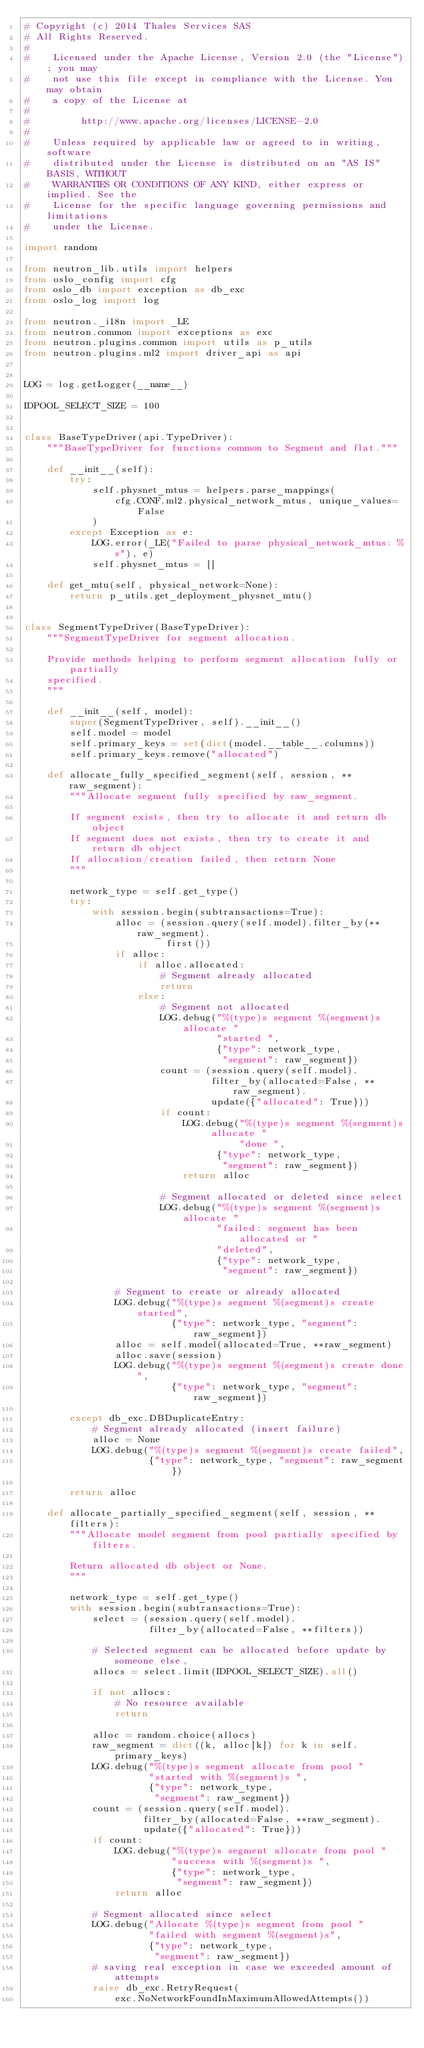Convert code to text. <code><loc_0><loc_0><loc_500><loc_500><_Python_># Copyright (c) 2014 Thales Services SAS
# All Rights Reserved.
#
#    Licensed under the Apache License, Version 2.0 (the "License"); you may
#    not use this file except in compliance with the License. You may obtain
#    a copy of the License at
#
#         http://www.apache.org/licenses/LICENSE-2.0
#
#    Unless required by applicable law or agreed to in writing, software
#    distributed under the License is distributed on an "AS IS" BASIS, WITHOUT
#    WARRANTIES OR CONDITIONS OF ANY KIND, either express or implied. See the
#    License for the specific language governing permissions and limitations
#    under the License.

import random

from neutron_lib.utils import helpers
from oslo_config import cfg
from oslo_db import exception as db_exc
from oslo_log import log

from neutron._i18n import _LE
from neutron.common import exceptions as exc
from neutron.plugins.common import utils as p_utils
from neutron.plugins.ml2 import driver_api as api


LOG = log.getLogger(__name__)

IDPOOL_SELECT_SIZE = 100


class BaseTypeDriver(api.TypeDriver):
    """BaseTypeDriver for functions common to Segment and flat."""

    def __init__(self):
        try:
            self.physnet_mtus = helpers.parse_mappings(
                cfg.CONF.ml2.physical_network_mtus, unique_values=False
            )
        except Exception as e:
            LOG.error(_LE("Failed to parse physical_network_mtus: %s"), e)
            self.physnet_mtus = []

    def get_mtu(self, physical_network=None):
        return p_utils.get_deployment_physnet_mtu()


class SegmentTypeDriver(BaseTypeDriver):
    """SegmentTypeDriver for segment allocation.

    Provide methods helping to perform segment allocation fully or partially
    specified.
    """

    def __init__(self, model):
        super(SegmentTypeDriver, self).__init__()
        self.model = model
        self.primary_keys = set(dict(model.__table__.columns))
        self.primary_keys.remove("allocated")

    def allocate_fully_specified_segment(self, session, **raw_segment):
        """Allocate segment fully specified by raw_segment.

        If segment exists, then try to allocate it and return db object
        If segment does not exists, then try to create it and return db object
        If allocation/creation failed, then return None
        """

        network_type = self.get_type()
        try:
            with session.begin(subtransactions=True):
                alloc = (session.query(self.model).filter_by(**raw_segment).
                         first())
                if alloc:
                    if alloc.allocated:
                        # Segment already allocated
                        return
                    else:
                        # Segment not allocated
                        LOG.debug("%(type)s segment %(segment)s allocate "
                                  "started ",
                                  {"type": network_type,
                                   "segment": raw_segment})
                        count = (session.query(self.model).
                                 filter_by(allocated=False, **raw_segment).
                                 update({"allocated": True}))
                        if count:
                            LOG.debug("%(type)s segment %(segment)s allocate "
                                      "done ",
                                  {"type": network_type,
                                   "segment": raw_segment})
                            return alloc

                        # Segment allocated or deleted since select
                        LOG.debug("%(type)s segment %(segment)s allocate "
                                  "failed: segment has been allocated or "
                                  "deleted",
                                  {"type": network_type,
                                   "segment": raw_segment})

                # Segment to create or already allocated
                LOG.debug("%(type)s segment %(segment)s create started",
                          {"type": network_type, "segment": raw_segment})
                alloc = self.model(allocated=True, **raw_segment)
                alloc.save(session)
                LOG.debug("%(type)s segment %(segment)s create done",
                          {"type": network_type, "segment": raw_segment})

        except db_exc.DBDuplicateEntry:
            # Segment already allocated (insert failure)
            alloc = None
            LOG.debug("%(type)s segment %(segment)s create failed",
                      {"type": network_type, "segment": raw_segment})

        return alloc

    def allocate_partially_specified_segment(self, session, **filters):
        """Allocate model segment from pool partially specified by filters.

        Return allocated db object or None.
        """

        network_type = self.get_type()
        with session.begin(subtransactions=True):
            select = (session.query(self.model).
                      filter_by(allocated=False, **filters))

            # Selected segment can be allocated before update by someone else,
            allocs = select.limit(IDPOOL_SELECT_SIZE).all()

            if not allocs:
                # No resource available
                return

            alloc = random.choice(allocs)
            raw_segment = dict((k, alloc[k]) for k in self.primary_keys)
            LOG.debug("%(type)s segment allocate from pool "
                      "started with %(segment)s ",
                      {"type": network_type,
                       "segment": raw_segment})
            count = (session.query(self.model).
                     filter_by(allocated=False, **raw_segment).
                     update({"allocated": True}))
            if count:
                LOG.debug("%(type)s segment allocate from pool "
                          "success with %(segment)s ",
                          {"type": network_type,
                           "segment": raw_segment})
                return alloc

            # Segment allocated since select
            LOG.debug("Allocate %(type)s segment from pool "
                      "failed with segment %(segment)s",
                      {"type": network_type,
                       "segment": raw_segment})
            # saving real exception in case we exceeded amount of attempts
            raise db_exc.RetryRequest(
                exc.NoNetworkFoundInMaximumAllowedAttempts())
</code> 